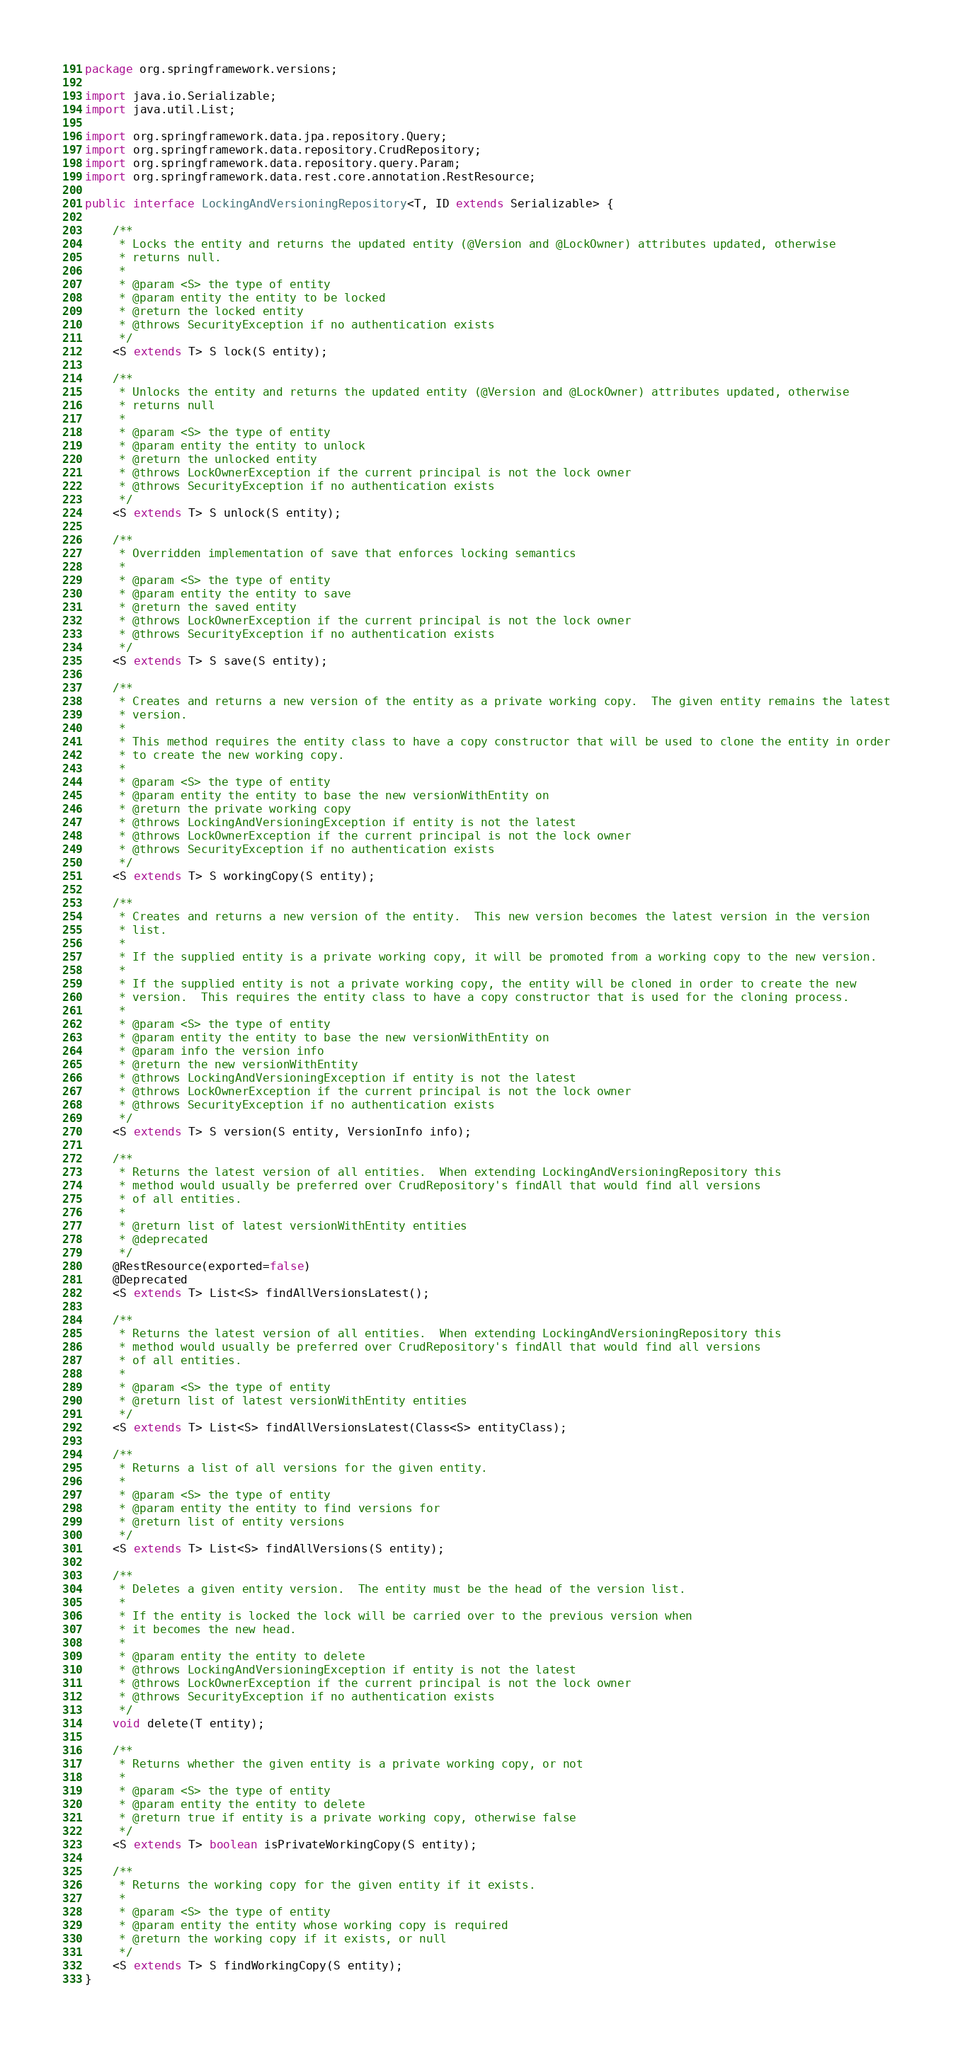Convert code to text. <code><loc_0><loc_0><loc_500><loc_500><_Java_>package org.springframework.versions;

import java.io.Serializable;
import java.util.List;

import org.springframework.data.jpa.repository.Query;
import org.springframework.data.repository.CrudRepository;
import org.springframework.data.repository.query.Param;
import org.springframework.data.rest.core.annotation.RestResource;

public interface LockingAndVersioningRepository<T, ID extends Serializable> {

    /**
     * Locks the entity and returns the updated entity (@Version and @LockOwner) attributes updated, otherwise
     * returns null.
     *
     * @param <S> the type of entity
     * @param entity the entity to be locked
     * @return the locked entity
     * @throws SecurityException if no authentication exists
     */
    <S extends T> S lock(S entity);

    /**
     * Unlocks the entity and returns the updated entity (@Version and @LockOwner) attributes updated, otherwise
     * returns null
     *
     * @param <S> the type of entity
     * @param entity the entity to unlock
     * @return the unlocked entity
     * @throws LockOwnerException if the current principal is not the lock owner
     * @throws SecurityException if no authentication exists
     */
    <S extends T> S unlock(S entity);

    /**
     * Overridden implementation of save that enforces locking semantics
     *
     * @param <S> the type of entity
     * @param entity the entity to save
     * @return the saved entity
     * @throws LockOwnerException if the current principal is not the lock owner
     * @throws SecurityException if no authentication exists
     */
    <S extends T> S save(S entity);

    /**
     * Creates and returns a new version of the entity as a private working copy.  The given entity remains the latest
     * version.
     *
     * This method requires the entity class to have a copy constructor that will be used to clone the entity in order
     * to create the new working copy.
     *
     * @param <S> the type of entity
     * @param entity the entity to base the new versionWithEntity on
     * @return the private working copy
     * @throws LockingAndVersioningException if entity is not the latest
     * @throws LockOwnerException if the current principal is not the lock owner
     * @throws SecurityException if no authentication exists
     */
    <S extends T> S workingCopy(S entity);

    /**
     * Creates and returns a new version of the entity.  This new version becomes the latest version in the version
     * list.
     *
     * If the supplied entity is a private working copy, it will be promoted from a working copy to the new version.
     *
     * If the supplied entity is not a private working copy, the entity will be cloned in order to create the new
     * version.  This requires the entity class to have a copy constructor that is used for the cloning process.
     *
     * @param <S> the type of entity
     * @param entity the entity to base the new versionWithEntity on
     * @param info the version info
     * @return the new versionWithEntity
     * @throws LockingAndVersioningException if entity is not the latest
     * @throws LockOwnerException if the current principal is not the lock owner
     * @throws SecurityException if no authentication exists
     */
    <S extends T> S version(S entity, VersionInfo info);

    /**
     * Returns the latest version of all entities.  When extending LockingAndVersioningRepository this
     * method would usually be preferred over CrudRepository's findAll that would find all versions
     * of all entities.
     *
     * @return list of latest versionWithEntity entities
     * @deprecated
     */
    @RestResource(exported=false)
    @Deprecated
    <S extends T> List<S> findAllVersionsLatest();

    /**
     * Returns the latest version of all entities.  When extending LockingAndVersioningRepository this
     * method would usually be preferred over CrudRepository's findAll that would find all versions
     * of all entities.
     *
     * @param <S> the type of entity
     * @return list of latest versionWithEntity entities
     */
    <S extends T> List<S> findAllVersionsLatest(Class<S> entityClass);

    /**
     * Returns a list of all versions for the given entity.
     *
     * @param <S> the type of entity
     * @param entity the entity to find versions for
     * @return list of entity versions
     */
    <S extends T> List<S> findAllVersions(S entity);

    /**
     * Deletes a given entity version.  The entity must be the head of the version list.
     *
     * If the entity is locked the lock will be carried over to the previous version when
     * it becomes the new head.
     *
     * @param entity the entity to delete
     * @throws LockingAndVersioningException if entity is not the latest
     * @throws LockOwnerException if the current principal is not the lock owner
     * @throws SecurityException if no authentication exists
     */
    void delete(T entity);

    /**
     * Returns whether the given entity is a private working copy, or not
     *
     * @param <S> the type of entity
     * @param entity the entity to delete
     * @return true if entity is a private working copy, otherwise false
     */
    <S extends T> boolean isPrivateWorkingCopy(S entity);

    /**
     * Returns the working copy for the given entity if it exists.
     *
     * @param <S> the type of entity
     * @param entity the entity whose working copy is required
     * @return the working copy if it exists, or null
     */
    <S extends T> S findWorkingCopy(S entity);
}
</code> 